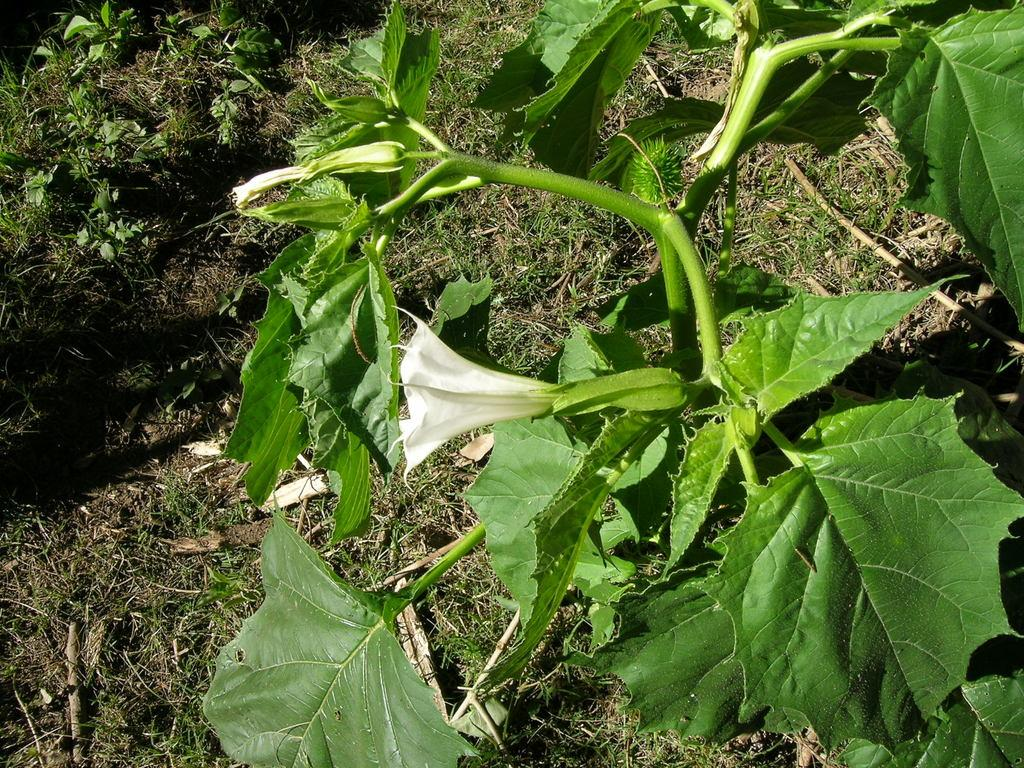What type of plant is visible in the image? There is a flower on a plant in the image. What type of vegetation can be seen in the image besides the flower? There is grass visible in the image. What type of measurement system is used to determine the length of the zipper in the image? There is no zipper present in the image, so it is not possible to determine the measurement system used. 